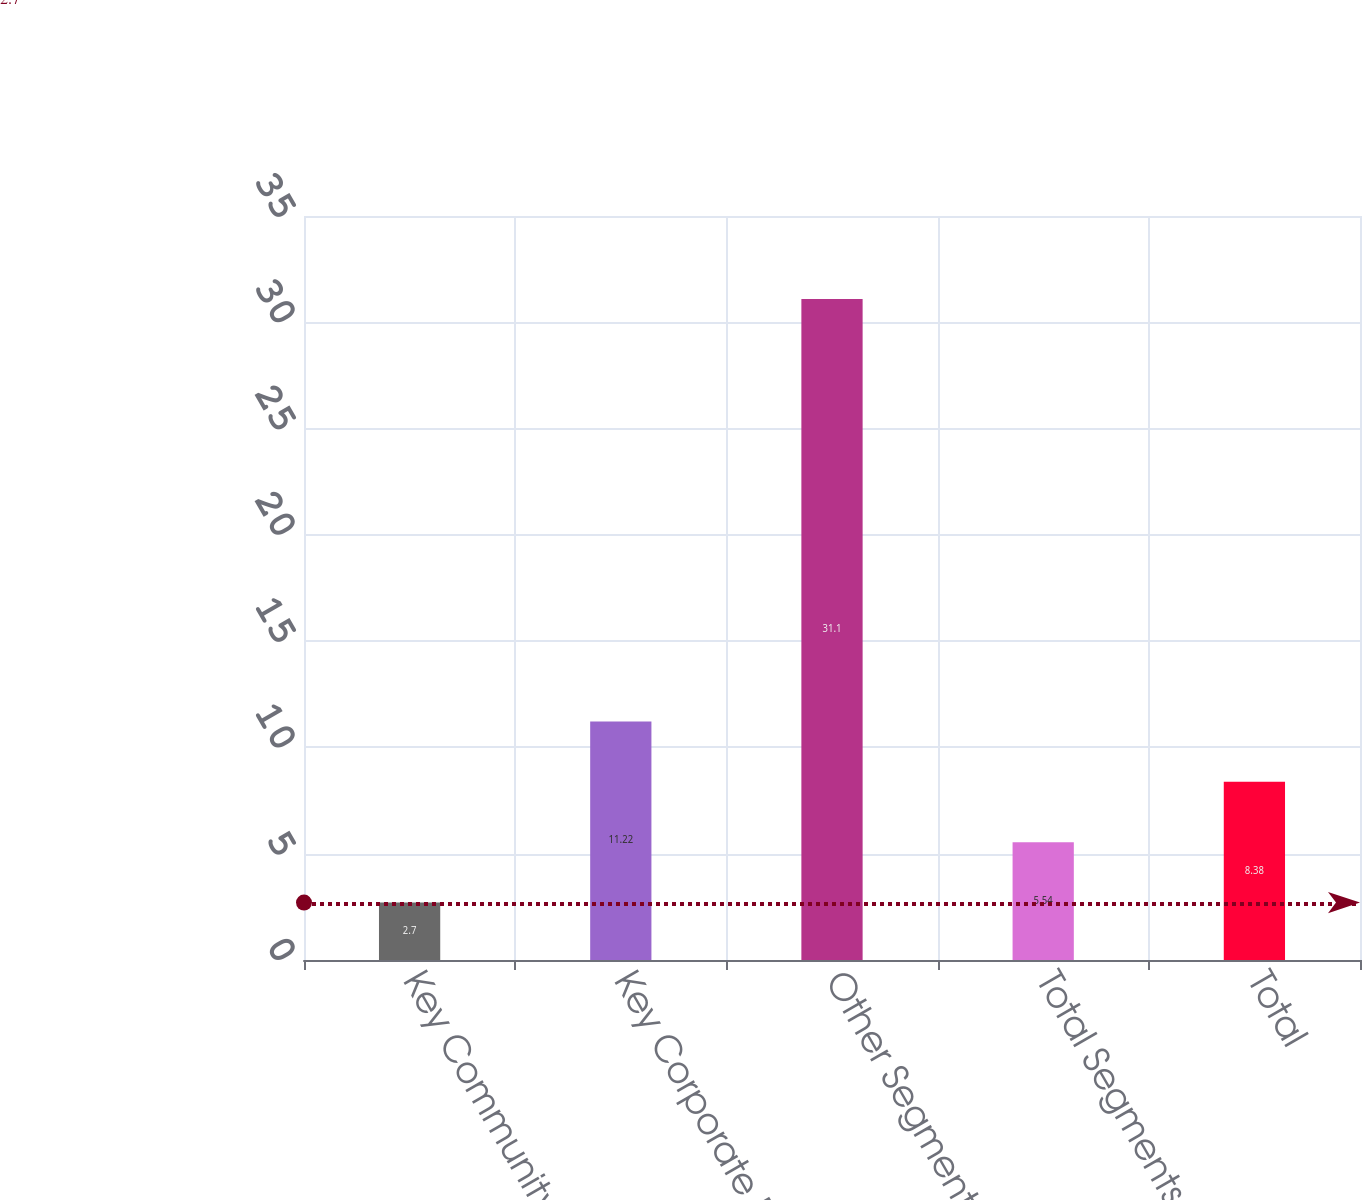Convert chart to OTSL. <chart><loc_0><loc_0><loc_500><loc_500><bar_chart><fcel>Key Community Bank<fcel>Key Corporate Bank<fcel>Other Segments<fcel>Total Segments<fcel>Total<nl><fcel>2.7<fcel>11.22<fcel>31.1<fcel>5.54<fcel>8.38<nl></chart> 